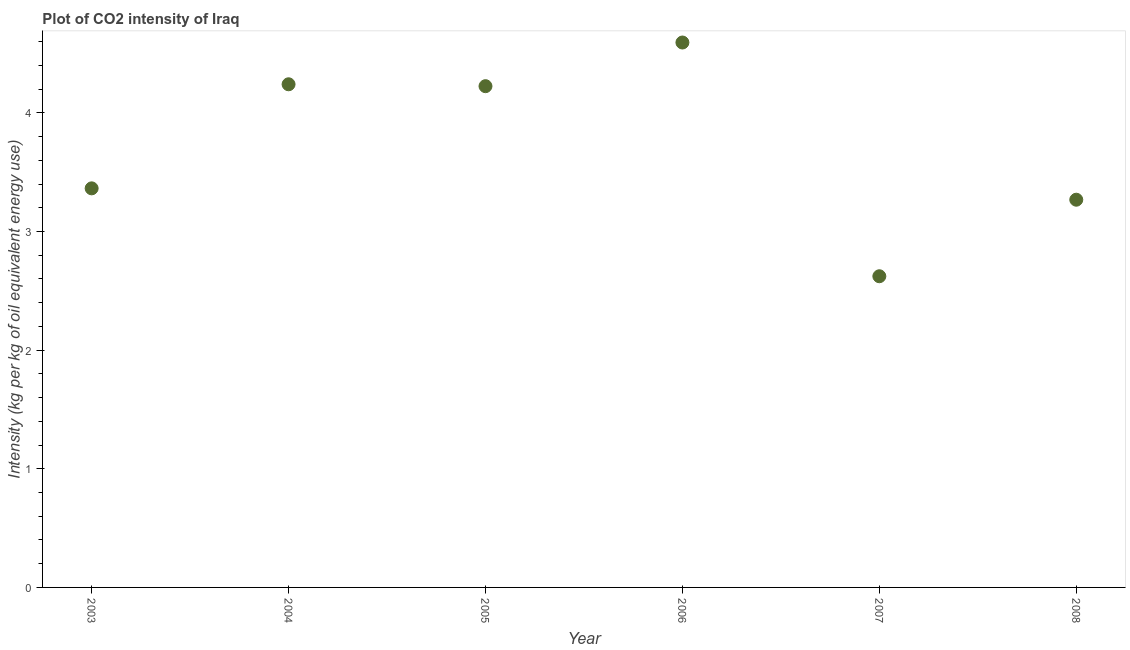What is the co2 intensity in 2007?
Make the answer very short. 2.62. Across all years, what is the maximum co2 intensity?
Your answer should be very brief. 4.59. Across all years, what is the minimum co2 intensity?
Provide a succinct answer. 2.62. In which year was the co2 intensity minimum?
Ensure brevity in your answer.  2007. What is the sum of the co2 intensity?
Provide a succinct answer. 22.32. What is the difference between the co2 intensity in 2004 and 2008?
Provide a short and direct response. 0.97. What is the average co2 intensity per year?
Give a very brief answer. 3.72. What is the median co2 intensity?
Make the answer very short. 3.79. In how many years, is the co2 intensity greater than 3 kg?
Offer a very short reply. 5. Do a majority of the years between 2005 and 2004 (inclusive) have co2 intensity greater than 3.8 kg?
Give a very brief answer. No. What is the ratio of the co2 intensity in 2004 to that in 2006?
Your answer should be compact. 0.92. Is the co2 intensity in 2006 less than that in 2007?
Make the answer very short. No. Is the difference between the co2 intensity in 2003 and 2005 greater than the difference between any two years?
Your answer should be very brief. No. What is the difference between the highest and the second highest co2 intensity?
Your answer should be very brief. 0.35. What is the difference between the highest and the lowest co2 intensity?
Give a very brief answer. 1.97. In how many years, is the co2 intensity greater than the average co2 intensity taken over all years?
Your answer should be very brief. 3. Does the co2 intensity monotonically increase over the years?
Give a very brief answer. No. Does the graph contain any zero values?
Your response must be concise. No. What is the title of the graph?
Make the answer very short. Plot of CO2 intensity of Iraq. What is the label or title of the X-axis?
Make the answer very short. Year. What is the label or title of the Y-axis?
Give a very brief answer. Intensity (kg per kg of oil equivalent energy use). What is the Intensity (kg per kg of oil equivalent energy use) in 2003?
Your answer should be very brief. 3.36. What is the Intensity (kg per kg of oil equivalent energy use) in 2004?
Ensure brevity in your answer.  4.24. What is the Intensity (kg per kg of oil equivalent energy use) in 2005?
Keep it short and to the point. 4.23. What is the Intensity (kg per kg of oil equivalent energy use) in 2006?
Offer a very short reply. 4.59. What is the Intensity (kg per kg of oil equivalent energy use) in 2007?
Your answer should be compact. 2.62. What is the Intensity (kg per kg of oil equivalent energy use) in 2008?
Your answer should be very brief. 3.27. What is the difference between the Intensity (kg per kg of oil equivalent energy use) in 2003 and 2004?
Provide a succinct answer. -0.88. What is the difference between the Intensity (kg per kg of oil equivalent energy use) in 2003 and 2005?
Ensure brevity in your answer.  -0.86. What is the difference between the Intensity (kg per kg of oil equivalent energy use) in 2003 and 2006?
Make the answer very short. -1.23. What is the difference between the Intensity (kg per kg of oil equivalent energy use) in 2003 and 2007?
Make the answer very short. 0.74. What is the difference between the Intensity (kg per kg of oil equivalent energy use) in 2003 and 2008?
Make the answer very short. 0.1. What is the difference between the Intensity (kg per kg of oil equivalent energy use) in 2004 and 2005?
Your answer should be compact. 0.02. What is the difference between the Intensity (kg per kg of oil equivalent energy use) in 2004 and 2006?
Offer a very short reply. -0.35. What is the difference between the Intensity (kg per kg of oil equivalent energy use) in 2004 and 2007?
Offer a very short reply. 1.62. What is the difference between the Intensity (kg per kg of oil equivalent energy use) in 2004 and 2008?
Give a very brief answer. 0.97. What is the difference between the Intensity (kg per kg of oil equivalent energy use) in 2005 and 2006?
Your answer should be compact. -0.37. What is the difference between the Intensity (kg per kg of oil equivalent energy use) in 2005 and 2007?
Provide a succinct answer. 1.6. What is the difference between the Intensity (kg per kg of oil equivalent energy use) in 2005 and 2008?
Offer a terse response. 0.96. What is the difference between the Intensity (kg per kg of oil equivalent energy use) in 2006 and 2007?
Make the answer very short. 1.97. What is the difference between the Intensity (kg per kg of oil equivalent energy use) in 2006 and 2008?
Make the answer very short. 1.33. What is the difference between the Intensity (kg per kg of oil equivalent energy use) in 2007 and 2008?
Your answer should be very brief. -0.65. What is the ratio of the Intensity (kg per kg of oil equivalent energy use) in 2003 to that in 2004?
Offer a terse response. 0.79. What is the ratio of the Intensity (kg per kg of oil equivalent energy use) in 2003 to that in 2005?
Provide a short and direct response. 0.8. What is the ratio of the Intensity (kg per kg of oil equivalent energy use) in 2003 to that in 2006?
Your response must be concise. 0.73. What is the ratio of the Intensity (kg per kg of oil equivalent energy use) in 2003 to that in 2007?
Give a very brief answer. 1.28. What is the ratio of the Intensity (kg per kg of oil equivalent energy use) in 2004 to that in 2006?
Your response must be concise. 0.92. What is the ratio of the Intensity (kg per kg of oil equivalent energy use) in 2004 to that in 2007?
Ensure brevity in your answer.  1.62. What is the ratio of the Intensity (kg per kg of oil equivalent energy use) in 2004 to that in 2008?
Give a very brief answer. 1.3. What is the ratio of the Intensity (kg per kg of oil equivalent energy use) in 2005 to that in 2007?
Offer a very short reply. 1.61. What is the ratio of the Intensity (kg per kg of oil equivalent energy use) in 2005 to that in 2008?
Your answer should be compact. 1.29. What is the ratio of the Intensity (kg per kg of oil equivalent energy use) in 2006 to that in 2007?
Your response must be concise. 1.75. What is the ratio of the Intensity (kg per kg of oil equivalent energy use) in 2006 to that in 2008?
Your response must be concise. 1.41. What is the ratio of the Intensity (kg per kg of oil equivalent energy use) in 2007 to that in 2008?
Your response must be concise. 0.8. 